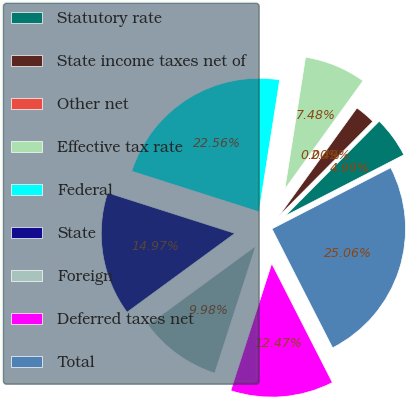Convert chart. <chart><loc_0><loc_0><loc_500><loc_500><pie_chart><fcel>Statutory rate<fcel>State income taxes net of<fcel>Other net<fcel>Effective tax rate<fcel>Federal<fcel>State<fcel>Foreign<fcel>Deferred taxes net<fcel>Total<nl><fcel>4.99%<fcel>2.49%<fcel>0.0%<fcel>7.48%<fcel>22.56%<fcel>14.97%<fcel>9.98%<fcel>12.47%<fcel>25.06%<nl></chart> 